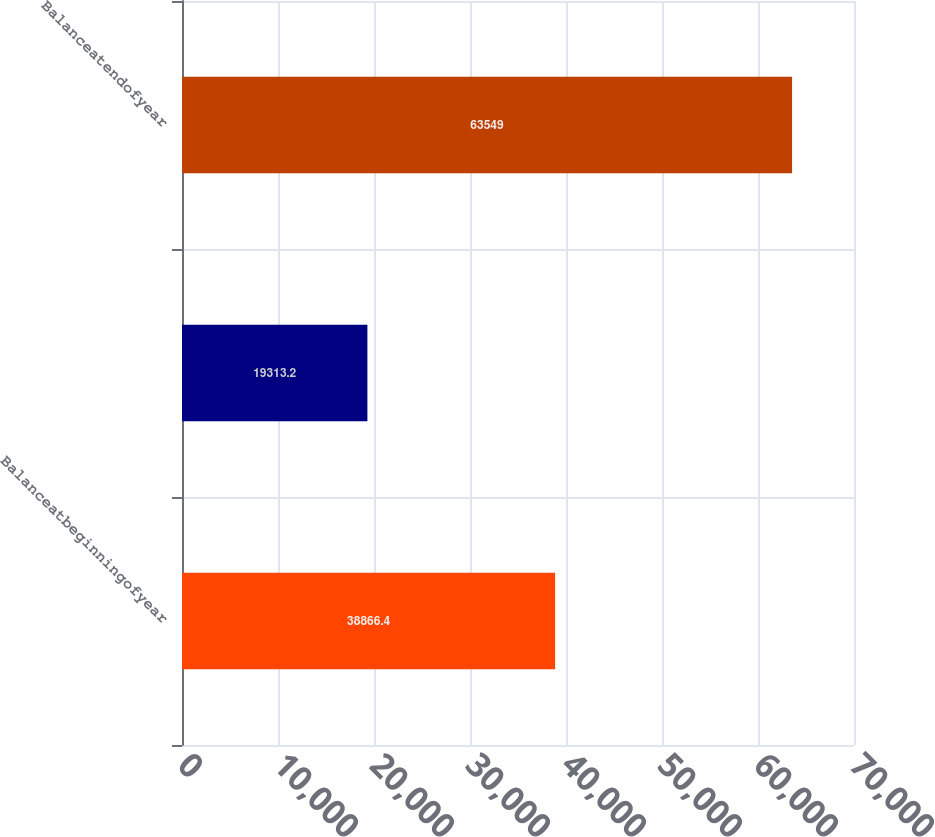Convert chart to OTSL. <chart><loc_0><loc_0><loc_500><loc_500><bar_chart><fcel>Balanceatbeginningofyear<fcel>Unnamed: 1<fcel>Balanceatendofyear<nl><fcel>38866.4<fcel>19313.2<fcel>63549<nl></chart> 